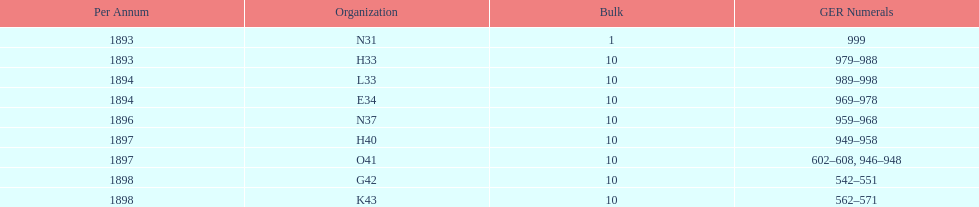Which year between 1893 and 1898 was there not an order? 1895. 